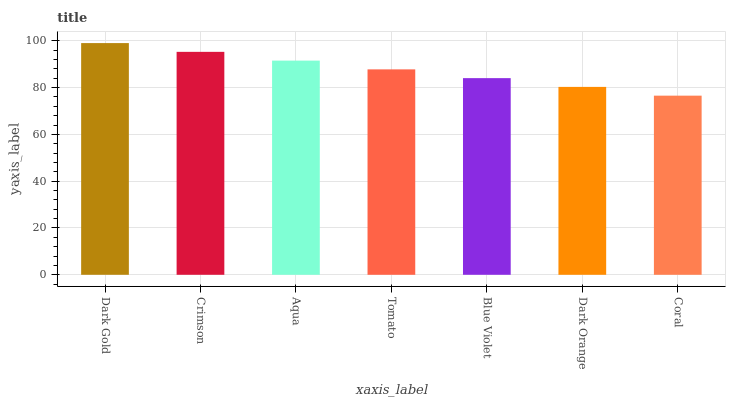Is Coral the minimum?
Answer yes or no. Yes. Is Dark Gold the maximum?
Answer yes or no. Yes. Is Crimson the minimum?
Answer yes or no. No. Is Crimson the maximum?
Answer yes or no. No. Is Dark Gold greater than Crimson?
Answer yes or no. Yes. Is Crimson less than Dark Gold?
Answer yes or no. Yes. Is Crimson greater than Dark Gold?
Answer yes or no. No. Is Dark Gold less than Crimson?
Answer yes or no. No. Is Tomato the high median?
Answer yes or no. Yes. Is Tomato the low median?
Answer yes or no. Yes. Is Blue Violet the high median?
Answer yes or no. No. Is Coral the low median?
Answer yes or no. No. 